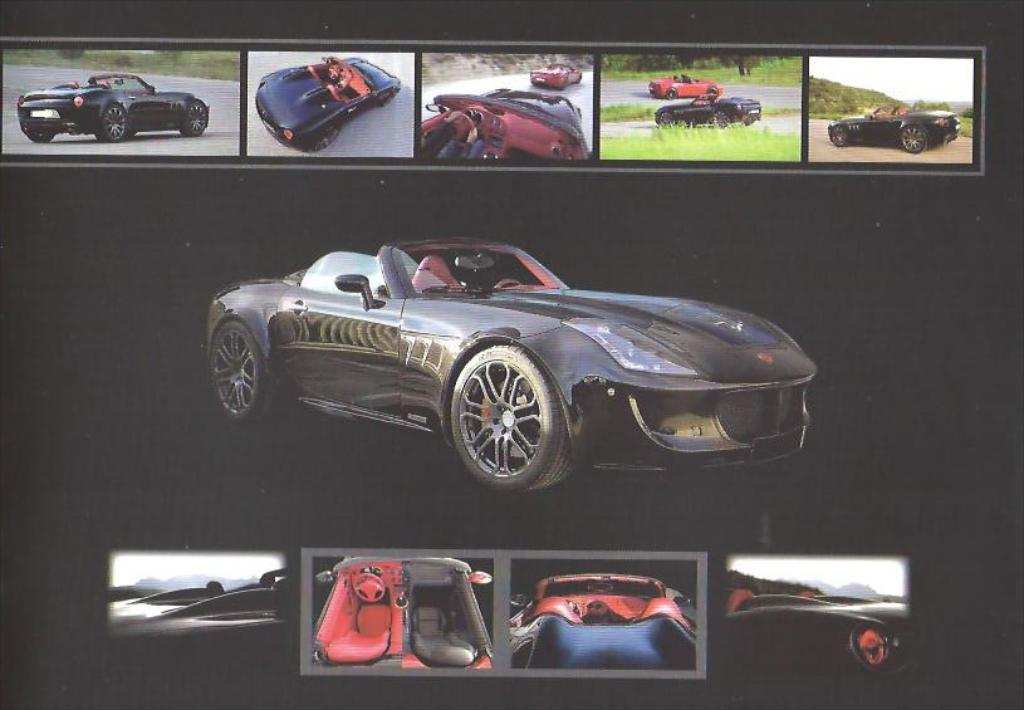What type of vehicles can be seen in the image? There are cars in the image. What is the ground surface like in the image? There is grass on the ground in the image. What else can be seen in the image besides cars? There are trees and mountains in the image. Are the cars in the image stationary or moving? Cars are moving on the road in the image. Can you see any cakes or quince in the image? No, there are no cakes or quince present in the image. 